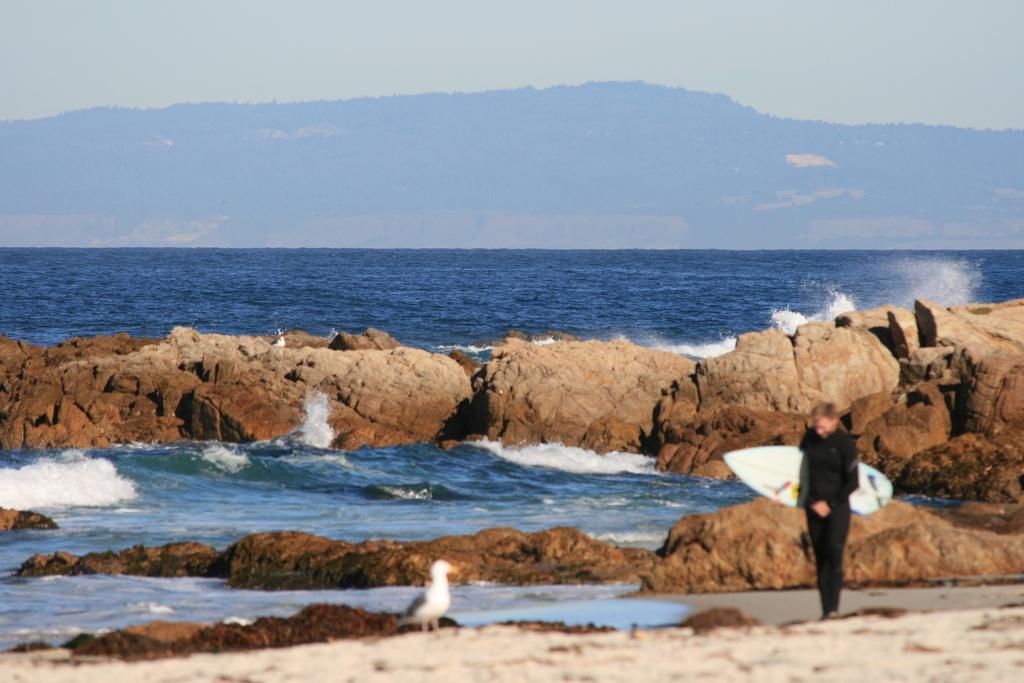Describe this image in one or two sentences. In this image I can see a person, a bird, water and a mountain. 